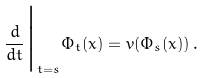Convert formula to latex. <formula><loc_0><loc_0><loc_500><loc_500>\frac { d } { d t } \Big | _ { t = s } \Phi _ { t } ( x ) = v ( \Phi _ { s } ( x ) ) \, .</formula> 